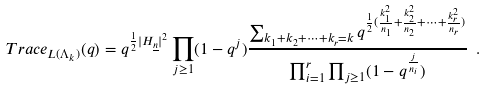<formula> <loc_0><loc_0><loc_500><loc_500>T r a c e _ { L ( \Lambda _ { k } ) } ( q ) = q ^ { \frac { 1 } { 2 } { | H _ { \underline { n } } | } ^ { 2 } } \prod _ { j \geq 1 } ( 1 - q ^ { j } ) \frac { \sum _ { k _ { 1 } + k _ { 2 } + \cdots + k _ { r } = k } q ^ { \frac { 1 } { 2 } ( \frac { k _ { 1 } ^ { 2 } } { n _ { 1 } } + \frac { k _ { 2 } ^ { 2 } } { n _ { 2 } } + \cdots + \frac { k _ { r } ^ { 2 } } { n _ { r } } ) } } { { \prod _ { i = 1 } ^ { r } \prod _ { j \geq 1 } ( 1 - q ^ { \frac { j } { n _ { i } } } ) } } \ .</formula> 